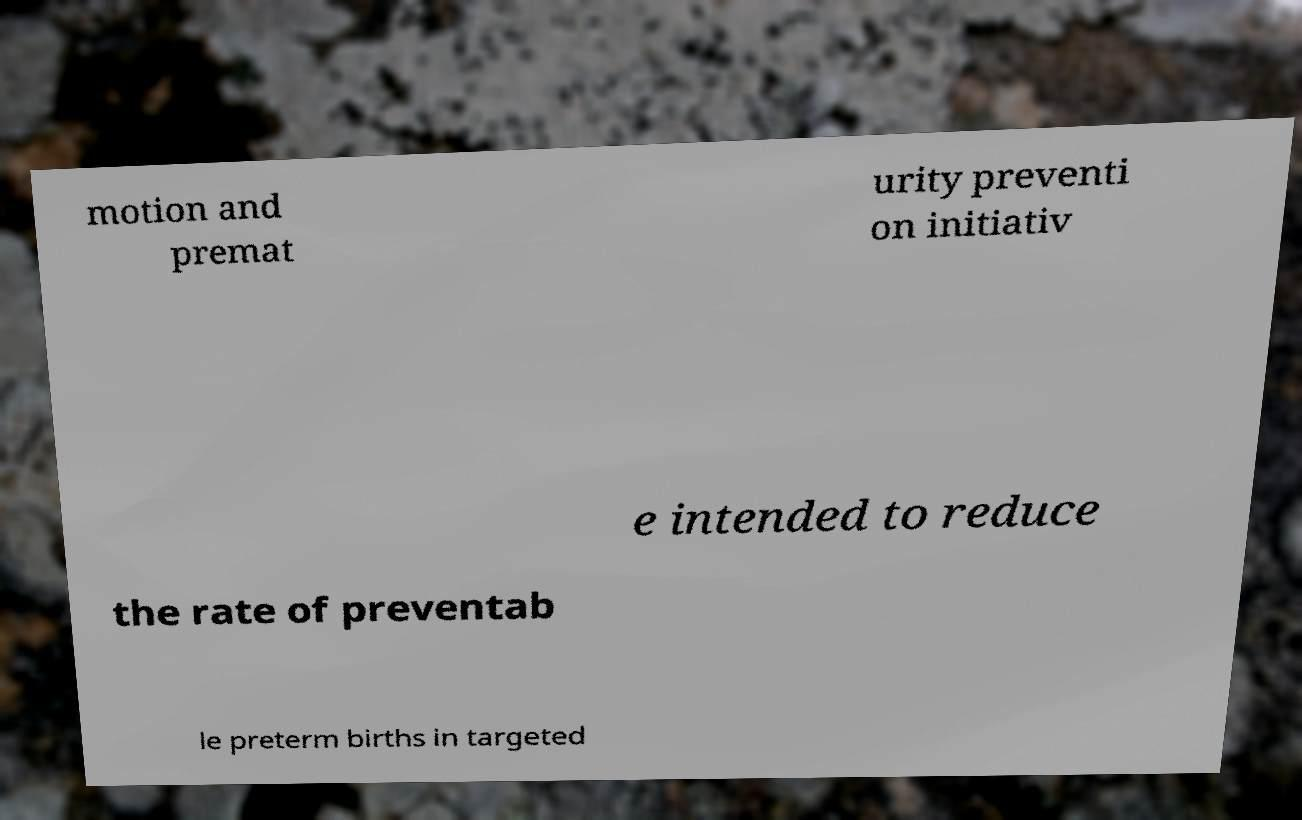Could you assist in decoding the text presented in this image and type it out clearly? motion and premat urity preventi on initiativ e intended to reduce the rate of preventab le preterm births in targeted 